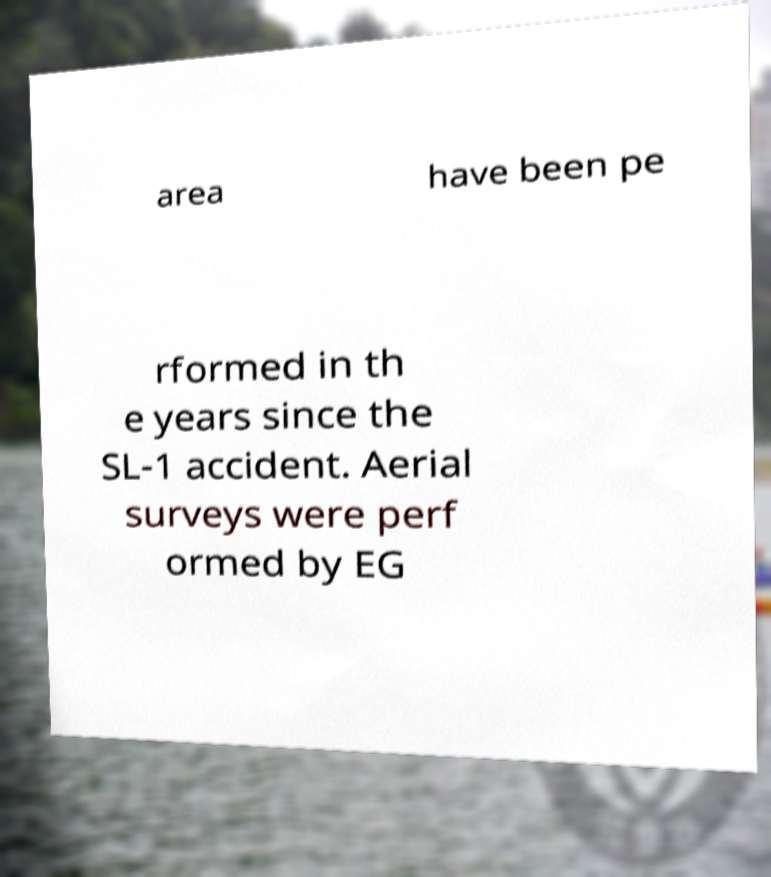Could you assist in decoding the text presented in this image and type it out clearly? area have been pe rformed in th e years since the SL-1 accident. Aerial surveys were perf ormed by EG 